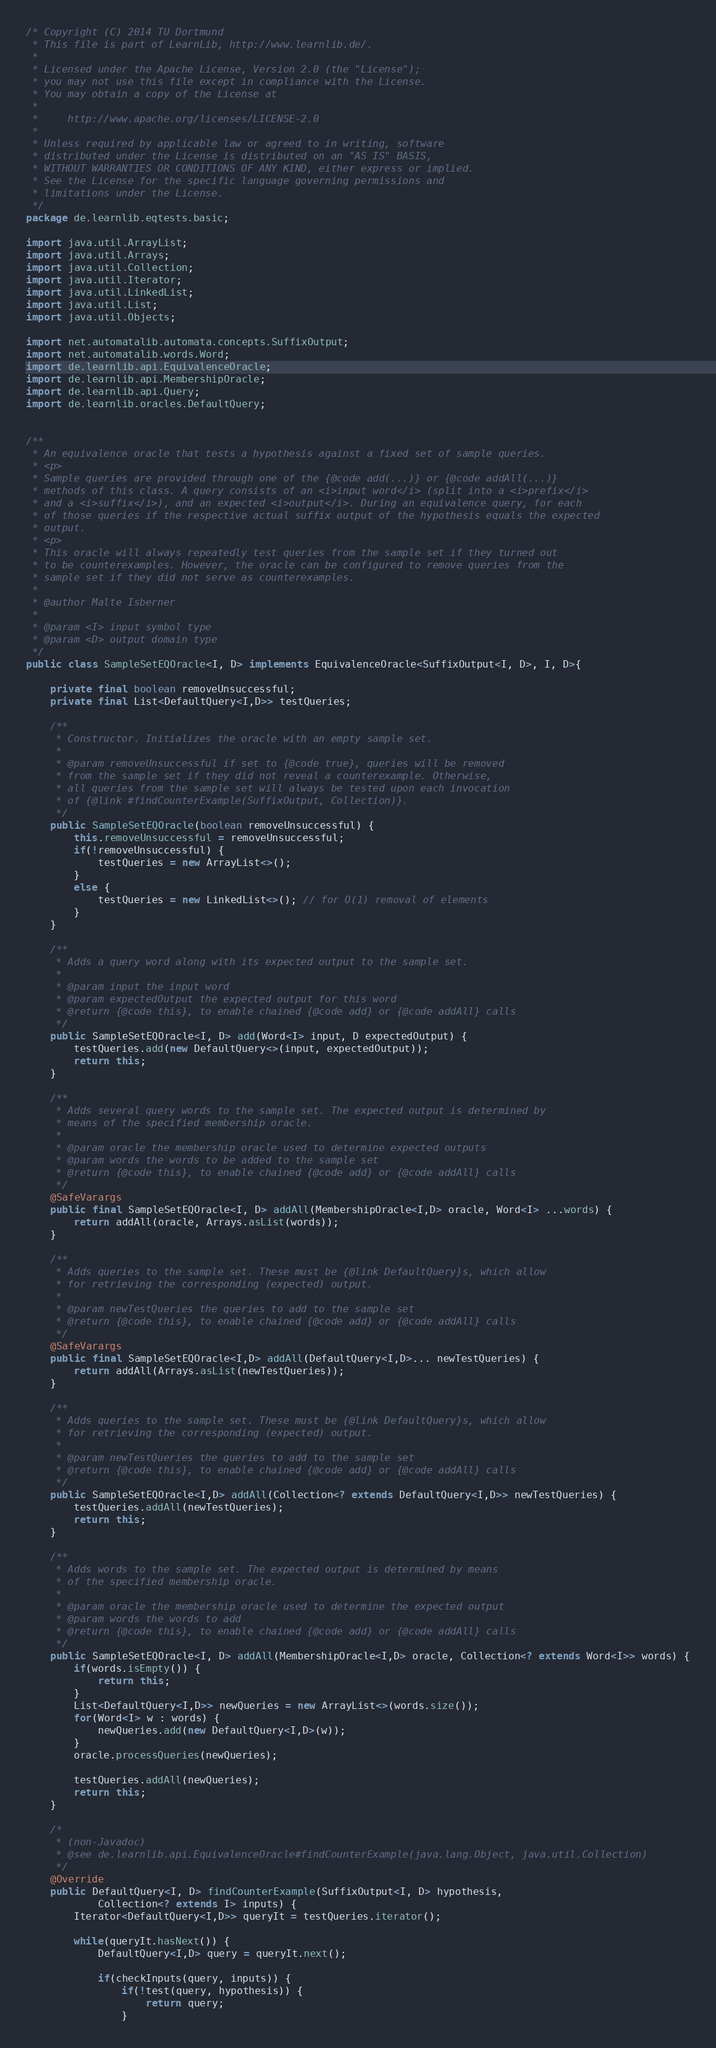<code> <loc_0><loc_0><loc_500><loc_500><_Java_>/* Copyright (C) 2014 TU Dortmund
 * This file is part of LearnLib, http://www.learnlib.de/.
 * 
 * Licensed under the Apache License, Version 2.0 (the "License");
 * you may not use this file except in compliance with the License.
 * You may obtain a copy of the License at
 * 
 *     http://www.apache.org/licenses/LICENSE-2.0
 * 
 * Unless required by applicable law or agreed to in writing, software
 * distributed under the License is distributed on an "AS IS" BASIS,
 * WITHOUT WARRANTIES OR CONDITIONS OF ANY KIND, either express or implied.
 * See the License for the specific language governing permissions and
 * limitations under the License.
 */
package de.learnlib.eqtests.basic;

import java.util.ArrayList;
import java.util.Arrays;
import java.util.Collection;
import java.util.Iterator;
import java.util.LinkedList;
import java.util.List;
import java.util.Objects;

import net.automatalib.automata.concepts.SuffixOutput;
import net.automatalib.words.Word;
import de.learnlib.api.EquivalenceOracle;
import de.learnlib.api.MembershipOracle;
import de.learnlib.api.Query;
import de.learnlib.oracles.DefaultQuery;


/**
 * An equivalence oracle that tests a hypothesis against a fixed set of sample queries.
 * <p>
 * Sample queries are provided through one of the {@code add(...)} or {@code addAll(...)}
 * methods of this class. A query consists of an <i>input word</i> (split into a <i>prefix</i>
 * and a <i>suffix</i>), and an expected <i>output</i>. During an equivalence query, for each
 * of those queries if the respective actual suffix output of the hypothesis equals the expected
 * output.
 * <p>
 * This oracle will always repeatedly test queries from the sample set if they turned out
 * to be counterexamples. However, the oracle can be configured to remove queries from the
 * sample set if they did not serve as counterexamples.
 * 
 * @author Malte Isberner
 *
 * @param <I> input symbol type
 * @param <D> output domain type
 */
public class SampleSetEQOracle<I, D> implements EquivalenceOracle<SuffixOutput<I, D>, I, D>{
	
	private final boolean removeUnsuccessful;
	private final List<DefaultQuery<I,D>> testQueries;
	
	/**
	 * Constructor. Initializes the oracle with an empty sample set.
	 * 
	 * @param removeUnsuccessful if set to {@code true}, queries will be removed
	 * from the sample set if they did not reveal a counterexample. Otherwise,
	 * all queries from the sample set will always be tested upon each invocation
	 * of {@link #findCounterExample(SuffixOutput, Collection)}.
	 */
	public SampleSetEQOracle(boolean removeUnsuccessful) {
		this.removeUnsuccessful = removeUnsuccessful;
		if(!removeUnsuccessful) {
			testQueries = new ArrayList<>();
		}
		else {
			testQueries = new LinkedList<>(); // for O(1) removal of elements
		}
	}
	
	/**
	 * Adds a query word along with its expected output to the sample set.
	 * 
	 * @param input the input word
	 * @param expectedOutput the expected output for this word
	 * @return {@code this}, to enable chained {@code add} or {@code addAll} calls
	 */
	public SampleSetEQOracle<I, D> add(Word<I> input, D expectedOutput) {
		testQueries.add(new DefaultQuery<>(input, expectedOutput));
		return this;
	}
	
	/**
	 * Adds several query words to the sample set. The expected output is determined by
	 * means of the specified membership oracle.
	 * 
	 * @param oracle the membership oracle used to determine expected outputs
	 * @param words the words to be added to the sample set
	 * @return {@code this}, to enable chained {@code add} or {@code addAll} calls
	 */
	@SafeVarargs
	public final SampleSetEQOracle<I, D> addAll(MembershipOracle<I,D> oracle, Word<I> ...words) {
		return addAll(oracle, Arrays.asList(words));
	}
	
	/**
	 * Adds queries to the sample set. These must be {@link DefaultQuery}s, which allow
	 * for retrieving the corresponding (expected) output.
	 * 
	 * @param newTestQueries the queries to add to the sample set
	 * @return {@code this}, to enable chained {@code add} or {@code addAll} calls
	 */
	@SafeVarargs
	public final SampleSetEQOracle<I,D> addAll(DefaultQuery<I,D>... newTestQueries) {
		return addAll(Arrays.asList(newTestQueries));
	}
	
	/**
	 * Adds queries to the sample set. These must be {@link DefaultQuery}s, which allow
	 * for retrieving the corresponding (expected) output.
	 * 
	 * @param newTestQueries the queries to add to the sample set
	 * @return {@code this}, to enable chained {@code add} or {@code addAll} calls
	 */
	public SampleSetEQOracle<I,D> addAll(Collection<? extends DefaultQuery<I,D>> newTestQueries) {
		testQueries.addAll(newTestQueries);
		return this;
	}
	
	/**
	 * Adds words to the sample set. The expected output is determined by means
	 * of the specified membership oracle.
	 * 
	 * @param oracle the membership oracle used to determine the expected output
	 * @param words the words to add
	 * @return {@code this}, to enable chained {@code add} or {@code addAll} calls
	 */
	public SampleSetEQOracle<I, D> addAll(MembershipOracle<I,D> oracle, Collection<? extends Word<I>> words) {
		if(words.isEmpty()) {
			return this;
		}
		List<DefaultQuery<I,D>> newQueries = new ArrayList<>(words.size());
		for(Word<I> w : words) {
			newQueries.add(new DefaultQuery<I,D>(w));
		}
		oracle.processQueries(newQueries);
		
		testQueries.addAll(newQueries);
		return this;
	}
	
	/*
	 * (non-Javadoc)
	 * @see de.learnlib.api.EquivalenceOracle#findCounterExample(java.lang.Object, java.util.Collection)
	 */
	@Override
	public DefaultQuery<I, D> findCounterExample(SuffixOutput<I, D> hypothesis,
			Collection<? extends I> inputs) {
		Iterator<DefaultQuery<I,D>> queryIt = testQueries.iterator();
		
		while(queryIt.hasNext()) {
			DefaultQuery<I,D> query = queryIt.next();
			
			if(checkInputs(query, inputs)) {
				if(!test(query, hypothesis)) {
					return query;
				}</code> 